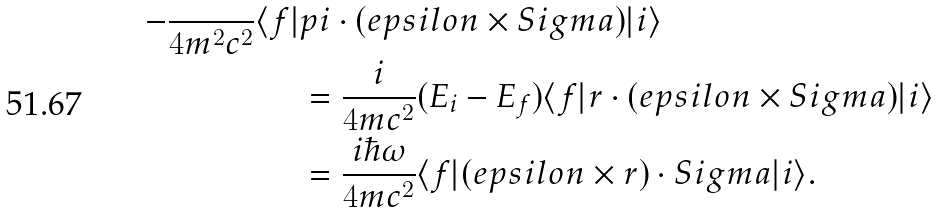Convert formula to latex. <formula><loc_0><loc_0><loc_500><loc_500>- \frac { } { 4 m ^ { 2 } c ^ { 2 } } \langle f | & p i \cdot ( e p s i l o n \times S i g m a ) | i \rangle \\ & = \frac { i } { 4 m c ^ { 2 } } ( E _ { i } - E _ { f } ) \langle f | r \cdot ( e p s i l o n \times S i g m a ) | i \rangle \\ & = \frac { i \hbar { \omega } } { 4 m c ^ { 2 } } \langle f | ( e p s i l o n \times r ) \cdot S i g m a | i \rangle .</formula> 